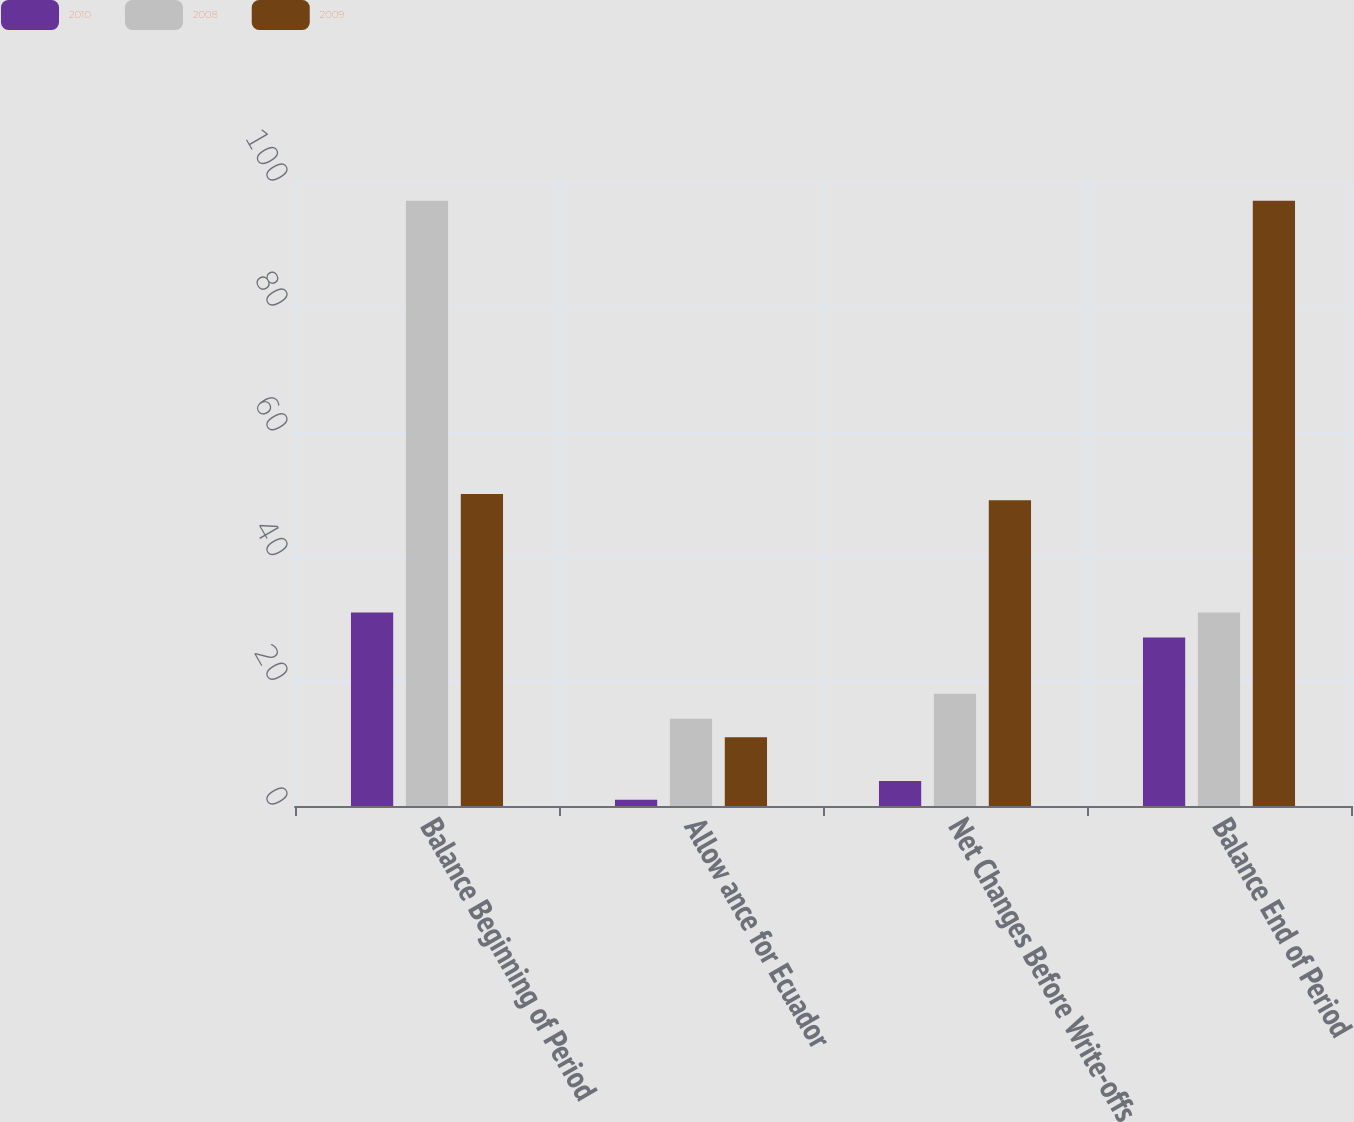<chart> <loc_0><loc_0><loc_500><loc_500><stacked_bar_chart><ecel><fcel>Balance Beginning of Period<fcel>Allow ance for Ecuador<fcel>Net Changes Before Write-offs<fcel>Balance End of Period<nl><fcel>2010<fcel>31<fcel>1<fcel>4<fcel>27<nl><fcel>2008<fcel>97<fcel>14<fcel>18<fcel>31<nl><fcel>2009<fcel>50<fcel>11<fcel>49<fcel>97<nl></chart> 